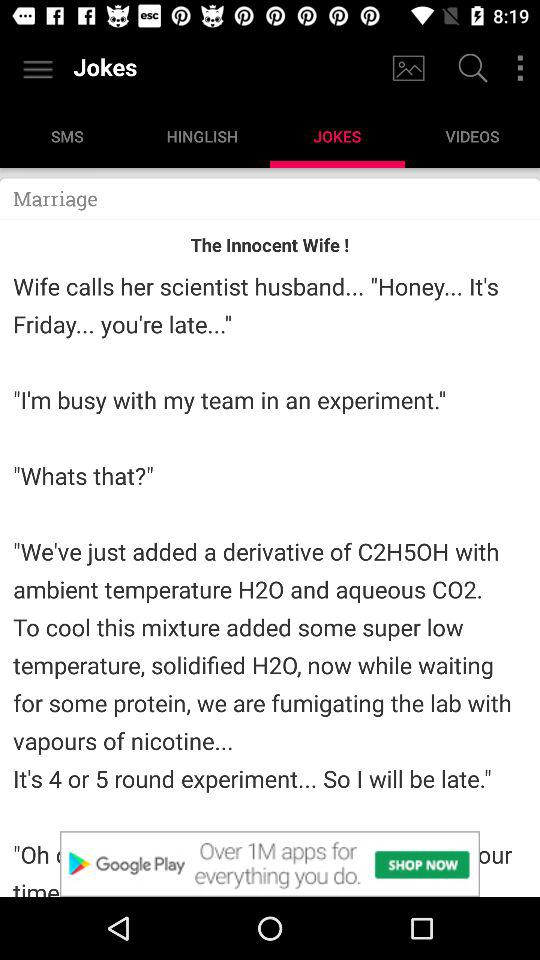How many round experiments will the scientist perform?
Answer the question using a single word or phrase. 4 or 5 